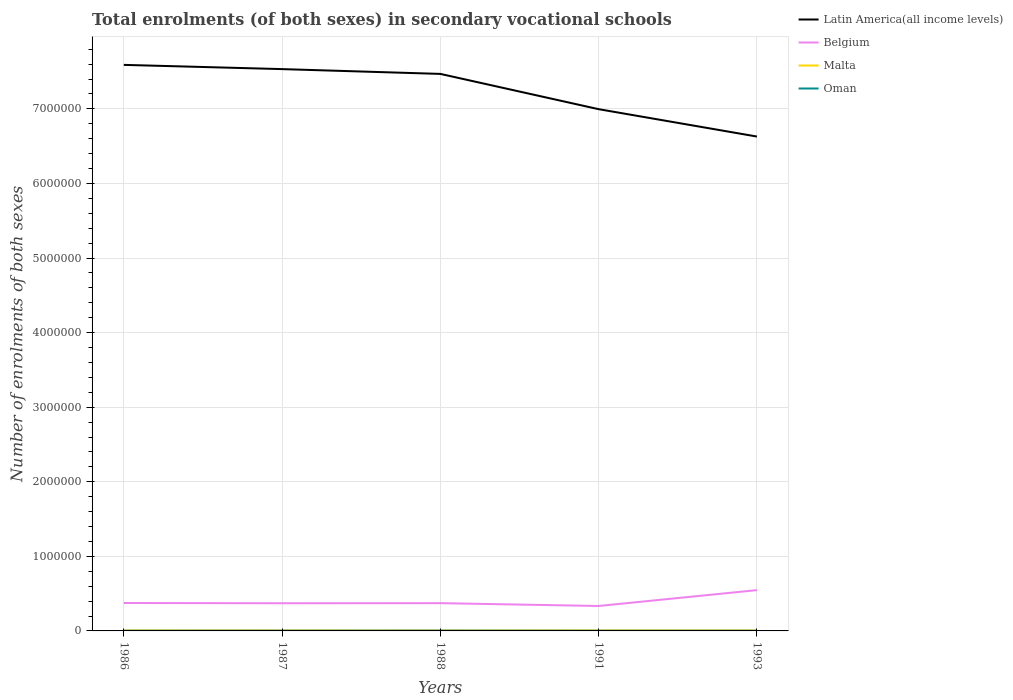Across all years, what is the maximum number of enrolments in secondary schools in Belgium?
Give a very brief answer. 3.34e+05. In which year was the number of enrolments in secondary schools in Malta maximum?
Provide a succinct answer. 1993. What is the total number of enrolments in secondary schools in Belgium in the graph?
Your answer should be compact. -1.75e+05. What is the difference between the highest and the second highest number of enrolments in secondary schools in Oman?
Your answer should be very brief. 1256. How many years are there in the graph?
Provide a succinct answer. 5. Are the values on the major ticks of Y-axis written in scientific E-notation?
Your response must be concise. No. Does the graph contain any zero values?
Keep it short and to the point. No. What is the title of the graph?
Your response must be concise. Total enrolments (of both sexes) in secondary vocational schools. What is the label or title of the X-axis?
Make the answer very short. Years. What is the label or title of the Y-axis?
Ensure brevity in your answer.  Number of enrolments of both sexes. What is the Number of enrolments of both sexes in Latin America(all income levels) in 1986?
Offer a terse response. 7.59e+06. What is the Number of enrolments of both sexes in Belgium in 1986?
Your response must be concise. 3.74e+05. What is the Number of enrolments of both sexes in Malta in 1986?
Your answer should be compact. 6358. What is the Number of enrolments of both sexes of Oman in 1986?
Your answer should be compact. 2374. What is the Number of enrolments of both sexes in Latin America(all income levels) in 1987?
Keep it short and to the point. 7.53e+06. What is the Number of enrolments of both sexes of Belgium in 1987?
Ensure brevity in your answer.  3.71e+05. What is the Number of enrolments of both sexes of Malta in 1987?
Provide a succinct answer. 6610. What is the Number of enrolments of both sexes in Oman in 1987?
Ensure brevity in your answer.  2986. What is the Number of enrolments of both sexes of Latin America(all income levels) in 1988?
Offer a very short reply. 7.47e+06. What is the Number of enrolments of both sexes of Belgium in 1988?
Offer a terse response. 3.72e+05. What is the Number of enrolments of both sexes in Malta in 1988?
Give a very brief answer. 6465. What is the Number of enrolments of both sexes of Oman in 1988?
Give a very brief answer. 3510. What is the Number of enrolments of both sexes in Latin America(all income levels) in 1991?
Provide a succinct answer. 7.00e+06. What is the Number of enrolments of both sexes of Belgium in 1991?
Ensure brevity in your answer.  3.34e+05. What is the Number of enrolments of both sexes in Malta in 1991?
Give a very brief answer. 6653. What is the Number of enrolments of both sexes in Oman in 1991?
Keep it short and to the point. 2391. What is the Number of enrolments of both sexes of Latin America(all income levels) in 1993?
Ensure brevity in your answer.  6.63e+06. What is the Number of enrolments of both sexes of Belgium in 1993?
Ensure brevity in your answer.  5.47e+05. What is the Number of enrolments of both sexes in Malta in 1993?
Offer a very short reply. 6200. What is the Number of enrolments of both sexes in Oman in 1993?
Give a very brief answer. 2254. Across all years, what is the maximum Number of enrolments of both sexes of Latin America(all income levels)?
Your response must be concise. 7.59e+06. Across all years, what is the maximum Number of enrolments of both sexes of Belgium?
Offer a terse response. 5.47e+05. Across all years, what is the maximum Number of enrolments of both sexes of Malta?
Provide a succinct answer. 6653. Across all years, what is the maximum Number of enrolments of both sexes in Oman?
Your response must be concise. 3510. Across all years, what is the minimum Number of enrolments of both sexes of Latin America(all income levels)?
Offer a terse response. 6.63e+06. Across all years, what is the minimum Number of enrolments of both sexes in Belgium?
Keep it short and to the point. 3.34e+05. Across all years, what is the minimum Number of enrolments of both sexes in Malta?
Your answer should be compact. 6200. Across all years, what is the minimum Number of enrolments of both sexes of Oman?
Ensure brevity in your answer.  2254. What is the total Number of enrolments of both sexes of Latin America(all income levels) in the graph?
Provide a short and direct response. 3.62e+07. What is the total Number of enrolments of both sexes of Belgium in the graph?
Provide a short and direct response. 2.00e+06. What is the total Number of enrolments of both sexes of Malta in the graph?
Offer a very short reply. 3.23e+04. What is the total Number of enrolments of both sexes in Oman in the graph?
Offer a terse response. 1.35e+04. What is the difference between the Number of enrolments of both sexes of Latin America(all income levels) in 1986 and that in 1987?
Provide a short and direct response. 5.69e+04. What is the difference between the Number of enrolments of both sexes in Belgium in 1986 and that in 1987?
Provide a short and direct response. 3223. What is the difference between the Number of enrolments of both sexes of Malta in 1986 and that in 1987?
Provide a succinct answer. -252. What is the difference between the Number of enrolments of both sexes in Oman in 1986 and that in 1987?
Ensure brevity in your answer.  -612. What is the difference between the Number of enrolments of both sexes of Latin America(all income levels) in 1986 and that in 1988?
Offer a very short reply. 1.21e+05. What is the difference between the Number of enrolments of both sexes in Belgium in 1986 and that in 1988?
Provide a short and direct response. 1952. What is the difference between the Number of enrolments of both sexes of Malta in 1986 and that in 1988?
Offer a very short reply. -107. What is the difference between the Number of enrolments of both sexes in Oman in 1986 and that in 1988?
Provide a short and direct response. -1136. What is the difference between the Number of enrolments of both sexes in Latin America(all income levels) in 1986 and that in 1991?
Keep it short and to the point. 5.94e+05. What is the difference between the Number of enrolments of both sexes of Belgium in 1986 and that in 1991?
Your answer should be very brief. 3.99e+04. What is the difference between the Number of enrolments of both sexes in Malta in 1986 and that in 1991?
Your answer should be very brief. -295. What is the difference between the Number of enrolments of both sexes in Latin America(all income levels) in 1986 and that in 1993?
Your response must be concise. 9.61e+05. What is the difference between the Number of enrolments of both sexes in Belgium in 1986 and that in 1993?
Your answer should be compact. -1.73e+05. What is the difference between the Number of enrolments of both sexes in Malta in 1986 and that in 1993?
Your answer should be very brief. 158. What is the difference between the Number of enrolments of both sexes of Oman in 1986 and that in 1993?
Your answer should be very brief. 120. What is the difference between the Number of enrolments of both sexes of Latin America(all income levels) in 1987 and that in 1988?
Your response must be concise. 6.42e+04. What is the difference between the Number of enrolments of both sexes of Belgium in 1987 and that in 1988?
Your answer should be very brief. -1271. What is the difference between the Number of enrolments of both sexes of Malta in 1987 and that in 1988?
Make the answer very short. 145. What is the difference between the Number of enrolments of both sexes of Oman in 1987 and that in 1988?
Your answer should be very brief. -524. What is the difference between the Number of enrolments of both sexes of Latin America(all income levels) in 1987 and that in 1991?
Your response must be concise. 5.37e+05. What is the difference between the Number of enrolments of both sexes of Belgium in 1987 and that in 1991?
Offer a terse response. 3.66e+04. What is the difference between the Number of enrolments of both sexes in Malta in 1987 and that in 1991?
Your answer should be compact. -43. What is the difference between the Number of enrolments of both sexes in Oman in 1987 and that in 1991?
Ensure brevity in your answer.  595. What is the difference between the Number of enrolments of both sexes in Latin America(all income levels) in 1987 and that in 1993?
Provide a succinct answer. 9.04e+05. What is the difference between the Number of enrolments of both sexes of Belgium in 1987 and that in 1993?
Your answer should be very brief. -1.76e+05. What is the difference between the Number of enrolments of both sexes of Malta in 1987 and that in 1993?
Provide a short and direct response. 410. What is the difference between the Number of enrolments of both sexes in Oman in 1987 and that in 1993?
Keep it short and to the point. 732. What is the difference between the Number of enrolments of both sexes of Latin America(all income levels) in 1988 and that in 1991?
Offer a terse response. 4.73e+05. What is the difference between the Number of enrolments of both sexes in Belgium in 1988 and that in 1991?
Offer a terse response. 3.79e+04. What is the difference between the Number of enrolments of both sexes of Malta in 1988 and that in 1991?
Make the answer very short. -188. What is the difference between the Number of enrolments of both sexes in Oman in 1988 and that in 1991?
Your answer should be compact. 1119. What is the difference between the Number of enrolments of both sexes in Latin America(all income levels) in 1988 and that in 1993?
Make the answer very short. 8.40e+05. What is the difference between the Number of enrolments of both sexes of Belgium in 1988 and that in 1993?
Give a very brief answer. -1.75e+05. What is the difference between the Number of enrolments of both sexes of Malta in 1988 and that in 1993?
Ensure brevity in your answer.  265. What is the difference between the Number of enrolments of both sexes of Oman in 1988 and that in 1993?
Your answer should be compact. 1256. What is the difference between the Number of enrolments of both sexes in Latin America(all income levels) in 1991 and that in 1993?
Your response must be concise. 3.67e+05. What is the difference between the Number of enrolments of both sexes of Belgium in 1991 and that in 1993?
Offer a terse response. -2.13e+05. What is the difference between the Number of enrolments of both sexes of Malta in 1991 and that in 1993?
Keep it short and to the point. 453. What is the difference between the Number of enrolments of both sexes of Oman in 1991 and that in 1993?
Provide a succinct answer. 137. What is the difference between the Number of enrolments of both sexes in Latin America(all income levels) in 1986 and the Number of enrolments of both sexes in Belgium in 1987?
Keep it short and to the point. 7.22e+06. What is the difference between the Number of enrolments of both sexes of Latin America(all income levels) in 1986 and the Number of enrolments of both sexes of Malta in 1987?
Provide a short and direct response. 7.58e+06. What is the difference between the Number of enrolments of both sexes of Latin America(all income levels) in 1986 and the Number of enrolments of both sexes of Oman in 1987?
Make the answer very short. 7.59e+06. What is the difference between the Number of enrolments of both sexes in Belgium in 1986 and the Number of enrolments of both sexes in Malta in 1987?
Your answer should be very brief. 3.68e+05. What is the difference between the Number of enrolments of both sexes of Belgium in 1986 and the Number of enrolments of both sexes of Oman in 1987?
Your answer should be compact. 3.71e+05. What is the difference between the Number of enrolments of both sexes in Malta in 1986 and the Number of enrolments of both sexes in Oman in 1987?
Make the answer very short. 3372. What is the difference between the Number of enrolments of both sexes of Latin America(all income levels) in 1986 and the Number of enrolments of both sexes of Belgium in 1988?
Offer a terse response. 7.22e+06. What is the difference between the Number of enrolments of both sexes in Latin America(all income levels) in 1986 and the Number of enrolments of both sexes in Malta in 1988?
Offer a very short reply. 7.58e+06. What is the difference between the Number of enrolments of both sexes of Latin America(all income levels) in 1986 and the Number of enrolments of both sexes of Oman in 1988?
Your answer should be very brief. 7.59e+06. What is the difference between the Number of enrolments of both sexes of Belgium in 1986 and the Number of enrolments of both sexes of Malta in 1988?
Offer a very short reply. 3.68e+05. What is the difference between the Number of enrolments of both sexes of Belgium in 1986 and the Number of enrolments of both sexes of Oman in 1988?
Ensure brevity in your answer.  3.71e+05. What is the difference between the Number of enrolments of both sexes of Malta in 1986 and the Number of enrolments of both sexes of Oman in 1988?
Your response must be concise. 2848. What is the difference between the Number of enrolments of both sexes of Latin America(all income levels) in 1986 and the Number of enrolments of both sexes of Belgium in 1991?
Provide a succinct answer. 7.26e+06. What is the difference between the Number of enrolments of both sexes of Latin America(all income levels) in 1986 and the Number of enrolments of both sexes of Malta in 1991?
Provide a succinct answer. 7.58e+06. What is the difference between the Number of enrolments of both sexes of Latin America(all income levels) in 1986 and the Number of enrolments of both sexes of Oman in 1991?
Make the answer very short. 7.59e+06. What is the difference between the Number of enrolments of both sexes in Belgium in 1986 and the Number of enrolments of both sexes in Malta in 1991?
Your response must be concise. 3.68e+05. What is the difference between the Number of enrolments of both sexes in Belgium in 1986 and the Number of enrolments of both sexes in Oman in 1991?
Offer a terse response. 3.72e+05. What is the difference between the Number of enrolments of both sexes in Malta in 1986 and the Number of enrolments of both sexes in Oman in 1991?
Provide a succinct answer. 3967. What is the difference between the Number of enrolments of both sexes in Latin America(all income levels) in 1986 and the Number of enrolments of both sexes in Belgium in 1993?
Your answer should be very brief. 7.04e+06. What is the difference between the Number of enrolments of both sexes of Latin America(all income levels) in 1986 and the Number of enrolments of both sexes of Malta in 1993?
Your response must be concise. 7.58e+06. What is the difference between the Number of enrolments of both sexes in Latin America(all income levels) in 1986 and the Number of enrolments of both sexes in Oman in 1993?
Provide a short and direct response. 7.59e+06. What is the difference between the Number of enrolments of both sexes in Belgium in 1986 and the Number of enrolments of both sexes in Malta in 1993?
Your answer should be very brief. 3.68e+05. What is the difference between the Number of enrolments of both sexes in Belgium in 1986 and the Number of enrolments of both sexes in Oman in 1993?
Ensure brevity in your answer.  3.72e+05. What is the difference between the Number of enrolments of both sexes of Malta in 1986 and the Number of enrolments of both sexes of Oman in 1993?
Your answer should be compact. 4104. What is the difference between the Number of enrolments of both sexes of Latin America(all income levels) in 1987 and the Number of enrolments of both sexes of Belgium in 1988?
Offer a terse response. 7.16e+06. What is the difference between the Number of enrolments of both sexes in Latin America(all income levels) in 1987 and the Number of enrolments of both sexes in Malta in 1988?
Offer a very short reply. 7.53e+06. What is the difference between the Number of enrolments of both sexes of Latin America(all income levels) in 1987 and the Number of enrolments of both sexes of Oman in 1988?
Your answer should be compact. 7.53e+06. What is the difference between the Number of enrolments of both sexes in Belgium in 1987 and the Number of enrolments of both sexes in Malta in 1988?
Your answer should be very brief. 3.65e+05. What is the difference between the Number of enrolments of both sexes of Belgium in 1987 and the Number of enrolments of both sexes of Oman in 1988?
Ensure brevity in your answer.  3.68e+05. What is the difference between the Number of enrolments of both sexes in Malta in 1987 and the Number of enrolments of both sexes in Oman in 1988?
Your answer should be very brief. 3100. What is the difference between the Number of enrolments of both sexes in Latin America(all income levels) in 1987 and the Number of enrolments of both sexes in Belgium in 1991?
Your answer should be very brief. 7.20e+06. What is the difference between the Number of enrolments of both sexes in Latin America(all income levels) in 1987 and the Number of enrolments of both sexes in Malta in 1991?
Make the answer very short. 7.53e+06. What is the difference between the Number of enrolments of both sexes of Latin America(all income levels) in 1987 and the Number of enrolments of both sexes of Oman in 1991?
Your answer should be compact. 7.53e+06. What is the difference between the Number of enrolments of both sexes in Belgium in 1987 and the Number of enrolments of both sexes in Malta in 1991?
Your answer should be very brief. 3.64e+05. What is the difference between the Number of enrolments of both sexes of Belgium in 1987 and the Number of enrolments of both sexes of Oman in 1991?
Provide a short and direct response. 3.69e+05. What is the difference between the Number of enrolments of both sexes of Malta in 1987 and the Number of enrolments of both sexes of Oman in 1991?
Provide a succinct answer. 4219. What is the difference between the Number of enrolments of both sexes in Latin America(all income levels) in 1987 and the Number of enrolments of both sexes in Belgium in 1993?
Provide a succinct answer. 6.99e+06. What is the difference between the Number of enrolments of both sexes in Latin America(all income levels) in 1987 and the Number of enrolments of both sexes in Malta in 1993?
Your answer should be very brief. 7.53e+06. What is the difference between the Number of enrolments of both sexes in Latin America(all income levels) in 1987 and the Number of enrolments of both sexes in Oman in 1993?
Provide a short and direct response. 7.53e+06. What is the difference between the Number of enrolments of both sexes of Belgium in 1987 and the Number of enrolments of both sexes of Malta in 1993?
Your answer should be compact. 3.65e+05. What is the difference between the Number of enrolments of both sexes in Belgium in 1987 and the Number of enrolments of both sexes in Oman in 1993?
Offer a terse response. 3.69e+05. What is the difference between the Number of enrolments of both sexes in Malta in 1987 and the Number of enrolments of both sexes in Oman in 1993?
Give a very brief answer. 4356. What is the difference between the Number of enrolments of both sexes in Latin America(all income levels) in 1988 and the Number of enrolments of both sexes in Belgium in 1991?
Make the answer very short. 7.13e+06. What is the difference between the Number of enrolments of both sexes of Latin America(all income levels) in 1988 and the Number of enrolments of both sexes of Malta in 1991?
Your response must be concise. 7.46e+06. What is the difference between the Number of enrolments of both sexes of Latin America(all income levels) in 1988 and the Number of enrolments of both sexes of Oman in 1991?
Your answer should be very brief. 7.47e+06. What is the difference between the Number of enrolments of both sexes in Belgium in 1988 and the Number of enrolments of both sexes in Malta in 1991?
Make the answer very short. 3.66e+05. What is the difference between the Number of enrolments of both sexes of Belgium in 1988 and the Number of enrolments of both sexes of Oman in 1991?
Make the answer very short. 3.70e+05. What is the difference between the Number of enrolments of both sexes of Malta in 1988 and the Number of enrolments of both sexes of Oman in 1991?
Your answer should be very brief. 4074. What is the difference between the Number of enrolments of both sexes of Latin America(all income levels) in 1988 and the Number of enrolments of both sexes of Belgium in 1993?
Offer a terse response. 6.92e+06. What is the difference between the Number of enrolments of both sexes in Latin America(all income levels) in 1988 and the Number of enrolments of both sexes in Malta in 1993?
Offer a terse response. 7.46e+06. What is the difference between the Number of enrolments of both sexes in Latin America(all income levels) in 1988 and the Number of enrolments of both sexes in Oman in 1993?
Your answer should be compact. 7.47e+06. What is the difference between the Number of enrolments of both sexes of Belgium in 1988 and the Number of enrolments of both sexes of Malta in 1993?
Your response must be concise. 3.66e+05. What is the difference between the Number of enrolments of both sexes in Belgium in 1988 and the Number of enrolments of both sexes in Oman in 1993?
Provide a short and direct response. 3.70e+05. What is the difference between the Number of enrolments of both sexes of Malta in 1988 and the Number of enrolments of both sexes of Oman in 1993?
Offer a terse response. 4211. What is the difference between the Number of enrolments of both sexes of Latin America(all income levels) in 1991 and the Number of enrolments of both sexes of Belgium in 1993?
Give a very brief answer. 6.45e+06. What is the difference between the Number of enrolments of both sexes of Latin America(all income levels) in 1991 and the Number of enrolments of both sexes of Malta in 1993?
Give a very brief answer. 6.99e+06. What is the difference between the Number of enrolments of both sexes of Latin America(all income levels) in 1991 and the Number of enrolments of both sexes of Oman in 1993?
Make the answer very short. 6.99e+06. What is the difference between the Number of enrolments of both sexes of Belgium in 1991 and the Number of enrolments of both sexes of Malta in 1993?
Provide a short and direct response. 3.28e+05. What is the difference between the Number of enrolments of both sexes of Belgium in 1991 and the Number of enrolments of both sexes of Oman in 1993?
Provide a short and direct response. 3.32e+05. What is the difference between the Number of enrolments of both sexes of Malta in 1991 and the Number of enrolments of both sexes of Oman in 1993?
Your answer should be compact. 4399. What is the average Number of enrolments of both sexes of Latin America(all income levels) per year?
Provide a succinct answer. 7.24e+06. What is the average Number of enrolments of both sexes of Belgium per year?
Make the answer very short. 4.00e+05. What is the average Number of enrolments of both sexes in Malta per year?
Provide a succinct answer. 6457.2. What is the average Number of enrolments of both sexes of Oman per year?
Keep it short and to the point. 2703. In the year 1986, what is the difference between the Number of enrolments of both sexes in Latin America(all income levels) and Number of enrolments of both sexes in Belgium?
Your answer should be compact. 7.22e+06. In the year 1986, what is the difference between the Number of enrolments of both sexes of Latin America(all income levels) and Number of enrolments of both sexes of Malta?
Give a very brief answer. 7.58e+06. In the year 1986, what is the difference between the Number of enrolments of both sexes in Latin America(all income levels) and Number of enrolments of both sexes in Oman?
Your response must be concise. 7.59e+06. In the year 1986, what is the difference between the Number of enrolments of both sexes of Belgium and Number of enrolments of both sexes of Malta?
Your answer should be very brief. 3.68e+05. In the year 1986, what is the difference between the Number of enrolments of both sexes of Belgium and Number of enrolments of both sexes of Oman?
Give a very brief answer. 3.72e+05. In the year 1986, what is the difference between the Number of enrolments of both sexes in Malta and Number of enrolments of both sexes in Oman?
Ensure brevity in your answer.  3984. In the year 1987, what is the difference between the Number of enrolments of both sexes of Latin America(all income levels) and Number of enrolments of both sexes of Belgium?
Offer a very short reply. 7.16e+06. In the year 1987, what is the difference between the Number of enrolments of both sexes in Latin America(all income levels) and Number of enrolments of both sexes in Malta?
Offer a terse response. 7.53e+06. In the year 1987, what is the difference between the Number of enrolments of both sexes in Latin America(all income levels) and Number of enrolments of both sexes in Oman?
Keep it short and to the point. 7.53e+06. In the year 1987, what is the difference between the Number of enrolments of both sexes of Belgium and Number of enrolments of both sexes of Malta?
Your answer should be compact. 3.65e+05. In the year 1987, what is the difference between the Number of enrolments of both sexes of Belgium and Number of enrolments of both sexes of Oman?
Ensure brevity in your answer.  3.68e+05. In the year 1987, what is the difference between the Number of enrolments of both sexes in Malta and Number of enrolments of both sexes in Oman?
Keep it short and to the point. 3624. In the year 1988, what is the difference between the Number of enrolments of both sexes of Latin America(all income levels) and Number of enrolments of both sexes of Belgium?
Your response must be concise. 7.10e+06. In the year 1988, what is the difference between the Number of enrolments of both sexes of Latin America(all income levels) and Number of enrolments of both sexes of Malta?
Give a very brief answer. 7.46e+06. In the year 1988, what is the difference between the Number of enrolments of both sexes in Latin America(all income levels) and Number of enrolments of both sexes in Oman?
Your answer should be very brief. 7.47e+06. In the year 1988, what is the difference between the Number of enrolments of both sexes of Belgium and Number of enrolments of both sexes of Malta?
Your response must be concise. 3.66e+05. In the year 1988, what is the difference between the Number of enrolments of both sexes of Belgium and Number of enrolments of both sexes of Oman?
Offer a terse response. 3.69e+05. In the year 1988, what is the difference between the Number of enrolments of both sexes in Malta and Number of enrolments of both sexes in Oman?
Give a very brief answer. 2955. In the year 1991, what is the difference between the Number of enrolments of both sexes in Latin America(all income levels) and Number of enrolments of both sexes in Belgium?
Your answer should be very brief. 6.66e+06. In the year 1991, what is the difference between the Number of enrolments of both sexes of Latin America(all income levels) and Number of enrolments of both sexes of Malta?
Keep it short and to the point. 6.99e+06. In the year 1991, what is the difference between the Number of enrolments of both sexes in Latin America(all income levels) and Number of enrolments of both sexes in Oman?
Provide a short and direct response. 6.99e+06. In the year 1991, what is the difference between the Number of enrolments of both sexes in Belgium and Number of enrolments of both sexes in Malta?
Keep it short and to the point. 3.28e+05. In the year 1991, what is the difference between the Number of enrolments of both sexes in Belgium and Number of enrolments of both sexes in Oman?
Offer a very short reply. 3.32e+05. In the year 1991, what is the difference between the Number of enrolments of both sexes in Malta and Number of enrolments of both sexes in Oman?
Ensure brevity in your answer.  4262. In the year 1993, what is the difference between the Number of enrolments of both sexes of Latin America(all income levels) and Number of enrolments of both sexes of Belgium?
Your response must be concise. 6.08e+06. In the year 1993, what is the difference between the Number of enrolments of both sexes of Latin America(all income levels) and Number of enrolments of both sexes of Malta?
Offer a terse response. 6.62e+06. In the year 1993, what is the difference between the Number of enrolments of both sexes in Latin America(all income levels) and Number of enrolments of both sexes in Oman?
Ensure brevity in your answer.  6.63e+06. In the year 1993, what is the difference between the Number of enrolments of both sexes in Belgium and Number of enrolments of both sexes in Malta?
Provide a succinct answer. 5.41e+05. In the year 1993, what is the difference between the Number of enrolments of both sexes in Belgium and Number of enrolments of both sexes in Oman?
Ensure brevity in your answer.  5.45e+05. In the year 1993, what is the difference between the Number of enrolments of both sexes of Malta and Number of enrolments of both sexes of Oman?
Provide a succinct answer. 3946. What is the ratio of the Number of enrolments of both sexes of Latin America(all income levels) in 1986 to that in 1987?
Provide a short and direct response. 1.01. What is the ratio of the Number of enrolments of both sexes in Belgium in 1986 to that in 1987?
Make the answer very short. 1.01. What is the ratio of the Number of enrolments of both sexes in Malta in 1986 to that in 1987?
Your answer should be compact. 0.96. What is the ratio of the Number of enrolments of both sexes in Oman in 1986 to that in 1987?
Your answer should be very brief. 0.8. What is the ratio of the Number of enrolments of both sexes in Latin America(all income levels) in 1986 to that in 1988?
Your response must be concise. 1.02. What is the ratio of the Number of enrolments of both sexes of Malta in 1986 to that in 1988?
Provide a short and direct response. 0.98. What is the ratio of the Number of enrolments of both sexes in Oman in 1986 to that in 1988?
Offer a terse response. 0.68. What is the ratio of the Number of enrolments of both sexes in Latin America(all income levels) in 1986 to that in 1991?
Give a very brief answer. 1.08. What is the ratio of the Number of enrolments of both sexes of Belgium in 1986 to that in 1991?
Keep it short and to the point. 1.12. What is the ratio of the Number of enrolments of both sexes in Malta in 1986 to that in 1991?
Offer a terse response. 0.96. What is the ratio of the Number of enrolments of both sexes in Oman in 1986 to that in 1991?
Provide a short and direct response. 0.99. What is the ratio of the Number of enrolments of both sexes in Latin America(all income levels) in 1986 to that in 1993?
Ensure brevity in your answer.  1.15. What is the ratio of the Number of enrolments of both sexes in Belgium in 1986 to that in 1993?
Your response must be concise. 0.68. What is the ratio of the Number of enrolments of both sexes of Malta in 1986 to that in 1993?
Make the answer very short. 1.03. What is the ratio of the Number of enrolments of both sexes in Oman in 1986 to that in 1993?
Give a very brief answer. 1.05. What is the ratio of the Number of enrolments of both sexes in Latin America(all income levels) in 1987 to that in 1988?
Your answer should be compact. 1.01. What is the ratio of the Number of enrolments of both sexes in Belgium in 1987 to that in 1988?
Your answer should be compact. 1. What is the ratio of the Number of enrolments of both sexes of Malta in 1987 to that in 1988?
Offer a very short reply. 1.02. What is the ratio of the Number of enrolments of both sexes of Oman in 1987 to that in 1988?
Give a very brief answer. 0.85. What is the ratio of the Number of enrolments of both sexes of Latin America(all income levels) in 1987 to that in 1991?
Your response must be concise. 1.08. What is the ratio of the Number of enrolments of both sexes in Belgium in 1987 to that in 1991?
Offer a very short reply. 1.11. What is the ratio of the Number of enrolments of both sexes of Malta in 1987 to that in 1991?
Your answer should be compact. 0.99. What is the ratio of the Number of enrolments of both sexes of Oman in 1987 to that in 1991?
Make the answer very short. 1.25. What is the ratio of the Number of enrolments of both sexes in Latin America(all income levels) in 1987 to that in 1993?
Your answer should be very brief. 1.14. What is the ratio of the Number of enrolments of both sexes in Belgium in 1987 to that in 1993?
Make the answer very short. 0.68. What is the ratio of the Number of enrolments of both sexes of Malta in 1987 to that in 1993?
Provide a succinct answer. 1.07. What is the ratio of the Number of enrolments of both sexes of Oman in 1987 to that in 1993?
Offer a very short reply. 1.32. What is the ratio of the Number of enrolments of both sexes in Latin America(all income levels) in 1988 to that in 1991?
Your response must be concise. 1.07. What is the ratio of the Number of enrolments of both sexes in Belgium in 1988 to that in 1991?
Keep it short and to the point. 1.11. What is the ratio of the Number of enrolments of both sexes of Malta in 1988 to that in 1991?
Provide a short and direct response. 0.97. What is the ratio of the Number of enrolments of both sexes in Oman in 1988 to that in 1991?
Your response must be concise. 1.47. What is the ratio of the Number of enrolments of both sexes of Latin America(all income levels) in 1988 to that in 1993?
Offer a very short reply. 1.13. What is the ratio of the Number of enrolments of both sexes in Belgium in 1988 to that in 1993?
Offer a terse response. 0.68. What is the ratio of the Number of enrolments of both sexes of Malta in 1988 to that in 1993?
Ensure brevity in your answer.  1.04. What is the ratio of the Number of enrolments of both sexes of Oman in 1988 to that in 1993?
Your answer should be very brief. 1.56. What is the ratio of the Number of enrolments of both sexes of Latin America(all income levels) in 1991 to that in 1993?
Offer a terse response. 1.06. What is the ratio of the Number of enrolments of both sexes of Belgium in 1991 to that in 1993?
Keep it short and to the point. 0.61. What is the ratio of the Number of enrolments of both sexes in Malta in 1991 to that in 1993?
Keep it short and to the point. 1.07. What is the ratio of the Number of enrolments of both sexes of Oman in 1991 to that in 1993?
Provide a succinct answer. 1.06. What is the difference between the highest and the second highest Number of enrolments of both sexes of Latin America(all income levels)?
Make the answer very short. 5.69e+04. What is the difference between the highest and the second highest Number of enrolments of both sexes of Belgium?
Your answer should be compact. 1.73e+05. What is the difference between the highest and the second highest Number of enrolments of both sexes of Oman?
Offer a terse response. 524. What is the difference between the highest and the lowest Number of enrolments of both sexes of Latin America(all income levels)?
Ensure brevity in your answer.  9.61e+05. What is the difference between the highest and the lowest Number of enrolments of both sexes of Belgium?
Ensure brevity in your answer.  2.13e+05. What is the difference between the highest and the lowest Number of enrolments of both sexes of Malta?
Make the answer very short. 453. What is the difference between the highest and the lowest Number of enrolments of both sexes in Oman?
Keep it short and to the point. 1256. 